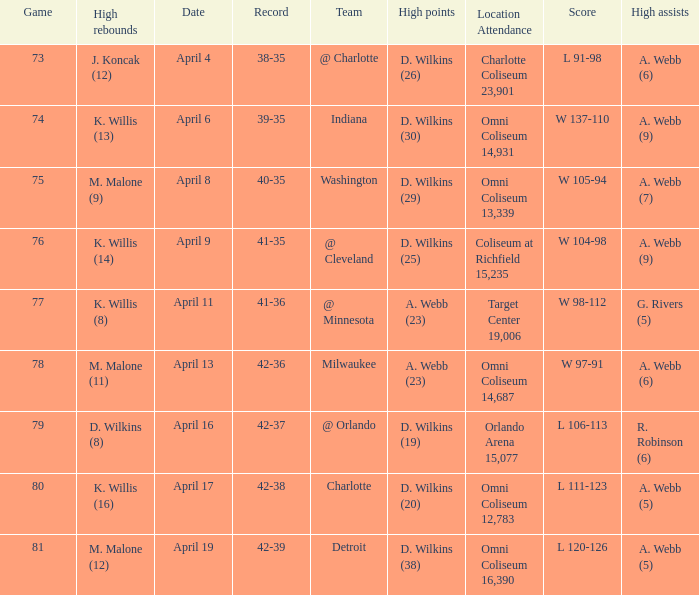Who had the high assists when the opponent was Indiana? A. Webb (9). 